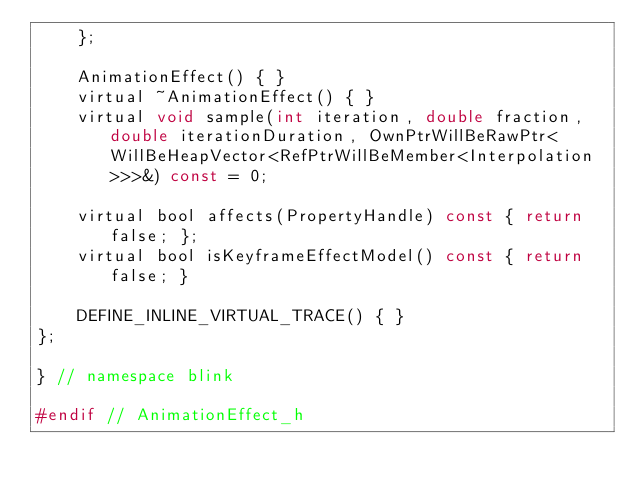<code> <loc_0><loc_0><loc_500><loc_500><_C_>    };

    AnimationEffect() { }
    virtual ~AnimationEffect() { }
    virtual void sample(int iteration, double fraction, double iterationDuration, OwnPtrWillBeRawPtr<WillBeHeapVector<RefPtrWillBeMember<Interpolation>>>&) const = 0;

    virtual bool affects(PropertyHandle) const { return false; };
    virtual bool isKeyframeEffectModel() const { return false; }

    DEFINE_INLINE_VIRTUAL_TRACE() { }
};

} // namespace blink

#endif // AnimationEffect_h
</code> 